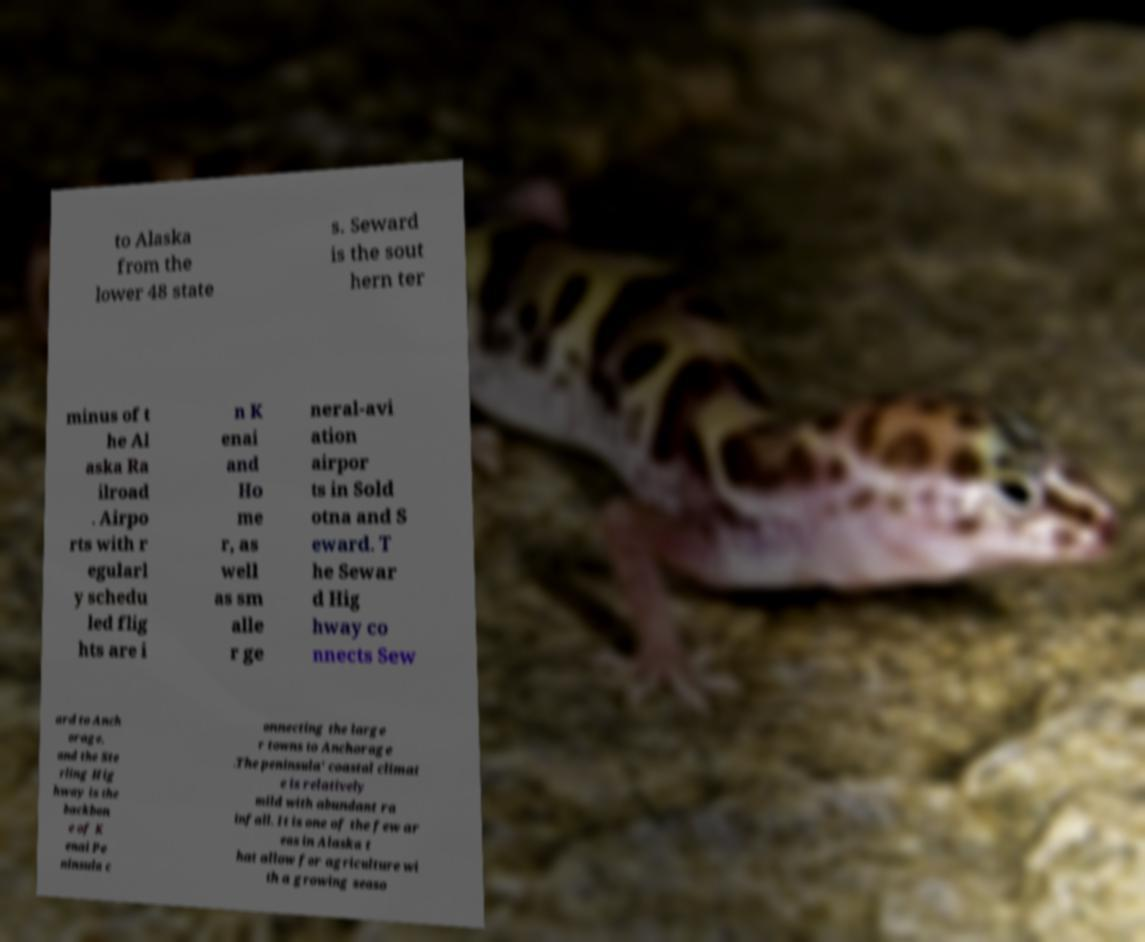I need the written content from this picture converted into text. Can you do that? to Alaska from the lower 48 state s. Seward is the sout hern ter minus of t he Al aska Ra ilroad . Airpo rts with r egularl y schedu led flig hts are i n K enai and Ho me r, as well as sm alle r ge neral-avi ation airpor ts in Sold otna and S eward. T he Sewar d Hig hway co nnects Sew ard to Anch orage, and the Ste rling Hig hway is the backbon e of K enai Pe ninsula c onnecting the large r towns to Anchorage .The peninsula' coastal climat e is relatively mild with abundant ra infall. It is one of the few ar eas in Alaska t hat allow for agriculture wi th a growing seaso 